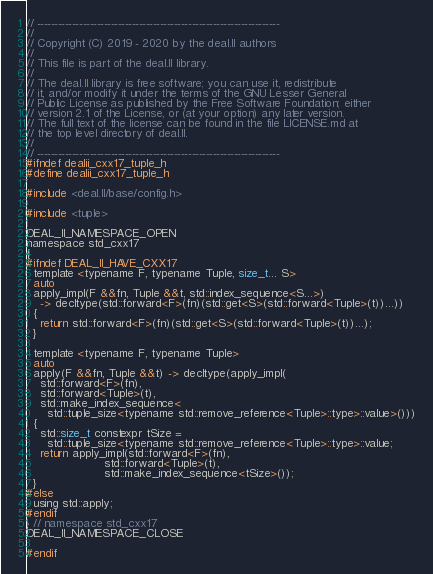Convert code to text. <code><loc_0><loc_0><loc_500><loc_500><_C_>// ---------------------------------------------------------------------
//
// Copyright (C) 2019 - 2020 by the deal.II authors
//
// This file is part of the deal.II library.
//
// The deal.II library is free software; you can use it, redistribute
// it, and/or modify it under the terms of the GNU Lesser General
// Public License as published by the Free Software Foundation; either
// version 2.1 of the License, or (at your option) any later version.
// The full text of the license can be found in the file LICENSE.md at
// the top level directory of deal.II.
//
// ---------------------------------------------------------------------
#ifndef dealii_cxx17_tuple_h
#define dealii_cxx17_tuple_h

#include <deal.II/base/config.h>

#include <tuple>

DEAL_II_NAMESPACE_OPEN
namespace std_cxx17
{
#ifndef DEAL_II_HAVE_CXX17
  template <typename F, typename Tuple, size_t... S>
  auto
  apply_impl(F &&fn, Tuple &&t, std::index_sequence<S...>)
    -> decltype(std::forward<F>(fn)(std::get<S>(std::forward<Tuple>(t))...))
  {
    return std::forward<F>(fn)(std::get<S>(std::forward<Tuple>(t))...);
  }

  template <typename F, typename Tuple>
  auto
  apply(F &&fn, Tuple &&t) -> decltype(apply_impl(
    std::forward<F>(fn),
    std::forward<Tuple>(t),
    std::make_index_sequence<
      std::tuple_size<typename std::remove_reference<Tuple>::type>::value>()))
  {
    std::size_t constexpr tSize =
      std::tuple_size<typename std::remove_reference<Tuple>::type>::value;
    return apply_impl(std::forward<F>(fn),
                      std::forward<Tuple>(t),
                      std::make_index_sequence<tSize>());
  }
#else
  using std::apply;
#endif
} // namespace std_cxx17
DEAL_II_NAMESPACE_CLOSE

#endif
</code> 